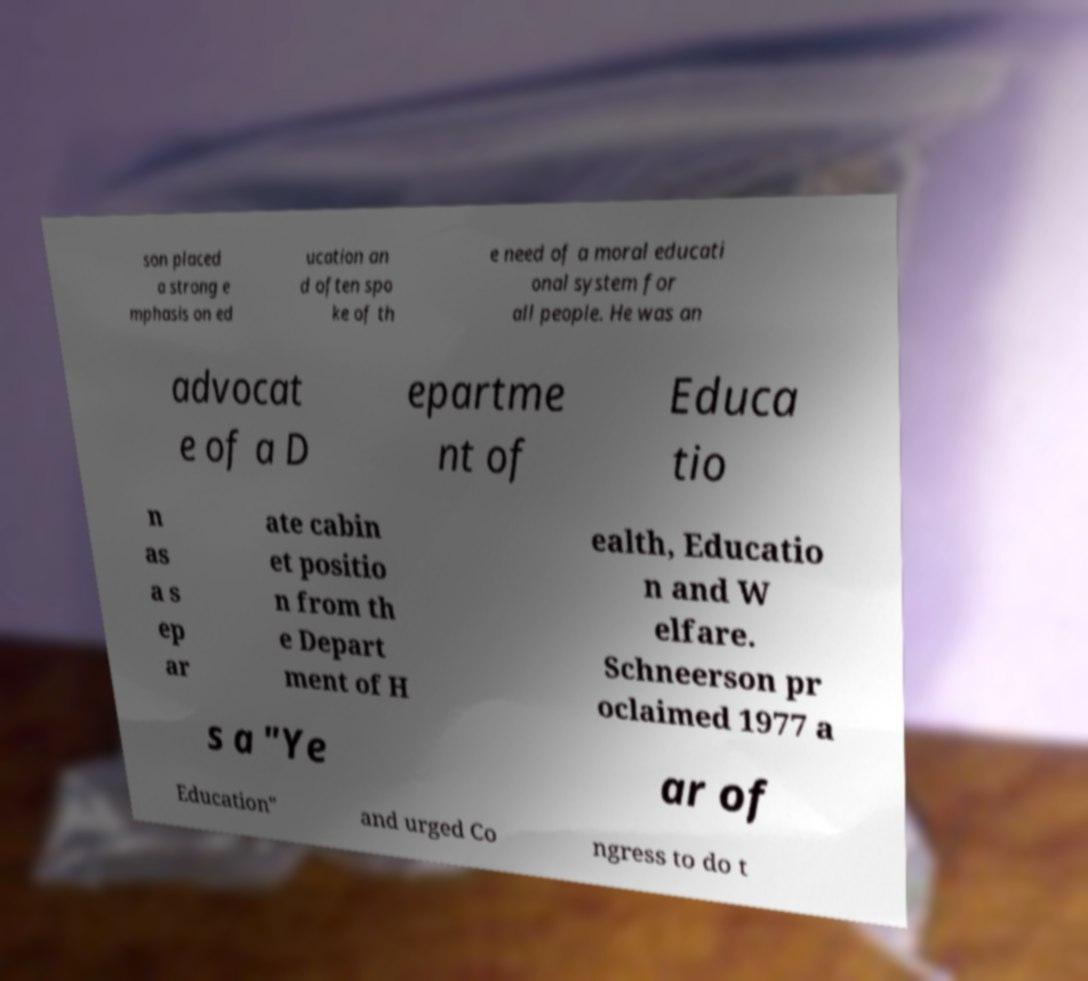Please read and relay the text visible in this image. What does it say? son placed a strong e mphasis on ed ucation an d often spo ke of th e need of a moral educati onal system for all people. He was an advocat e of a D epartme nt of Educa tio n as a s ep ar ate cabin et positio n from th e Depart ment of H ealth, Educatio n and W elfare. Schneerson pr oclaimed 1977 a s a "Ye ar of Education" and urged Co ngress to do t 